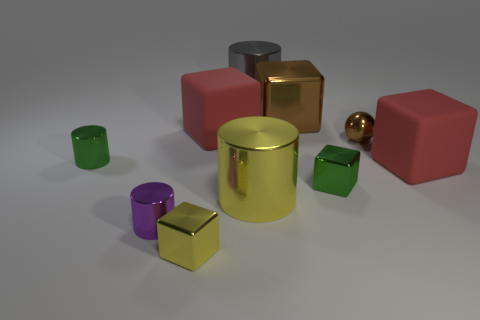Is the number of green cubes greater than the number of large blue rubber cylinders?
Keep it short and to the point. Yes. What number of other objects are there of the same color as the metallic ball?
Your response must be concise. 1. Does the yellow cube have the same material as the red thing behind the small green cylinder?
Provide a succinct answer. No. There is a green shiny thing that is right of the large cube left of the large brown thing; what number of brown shiny balls are in front of it?
Give a very brief answer. 0. Are there fewer big yellow cylinders that are left of the tiny purple cylinder than small green cylinders that are behind the green cylinder?
Your answer should be very brief. No. What number of other objects are the same material as the brown ball?
Offer a terse response. 7. What material is the other cylinder that is the same size as the yellow metallic cylinder?
Ensure brevity in your answer.  Metal. What number of cyan objects are either shiny cubes or small metallic balls?
Your answer should be compact. 0. What color is the metallic object that is left of the small yellow metal block and in front of the green cube?
Your response must be concise. Purple. Is the big red object to the right of the large yellow metal thing made of the same material as the large thing that is behind the large brown shiny thing?
Your response must be concise. No. 